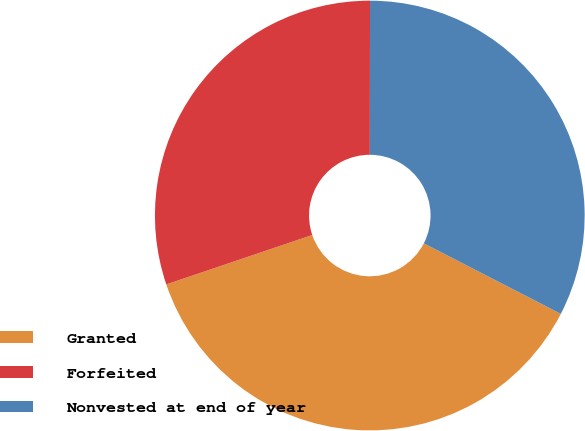Convert chart. <chart><loc_0><loc_0><loc_500><loc_500><pie_chart><fcel>Granted<fcel>Forfeited<fcel>Nonvested at end of year<nl><fcel>37.24%<fcel>30.21%<fcel>32.55%<nl></chart> 